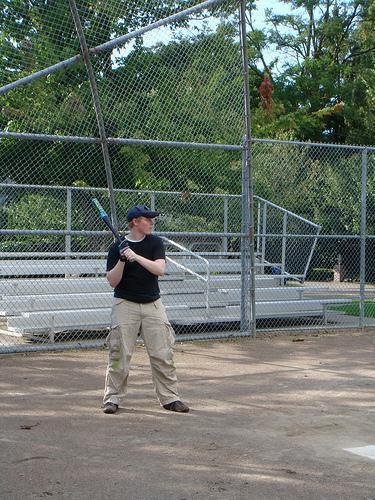How many people are shown?
Give a very brief answer. 1. How many rows of benches are there?
Give a very brief answer. 4. How many benches are there?
Give a very brief answer. 2. How many remote controls are visible?
Give a very brief answer. 0. 